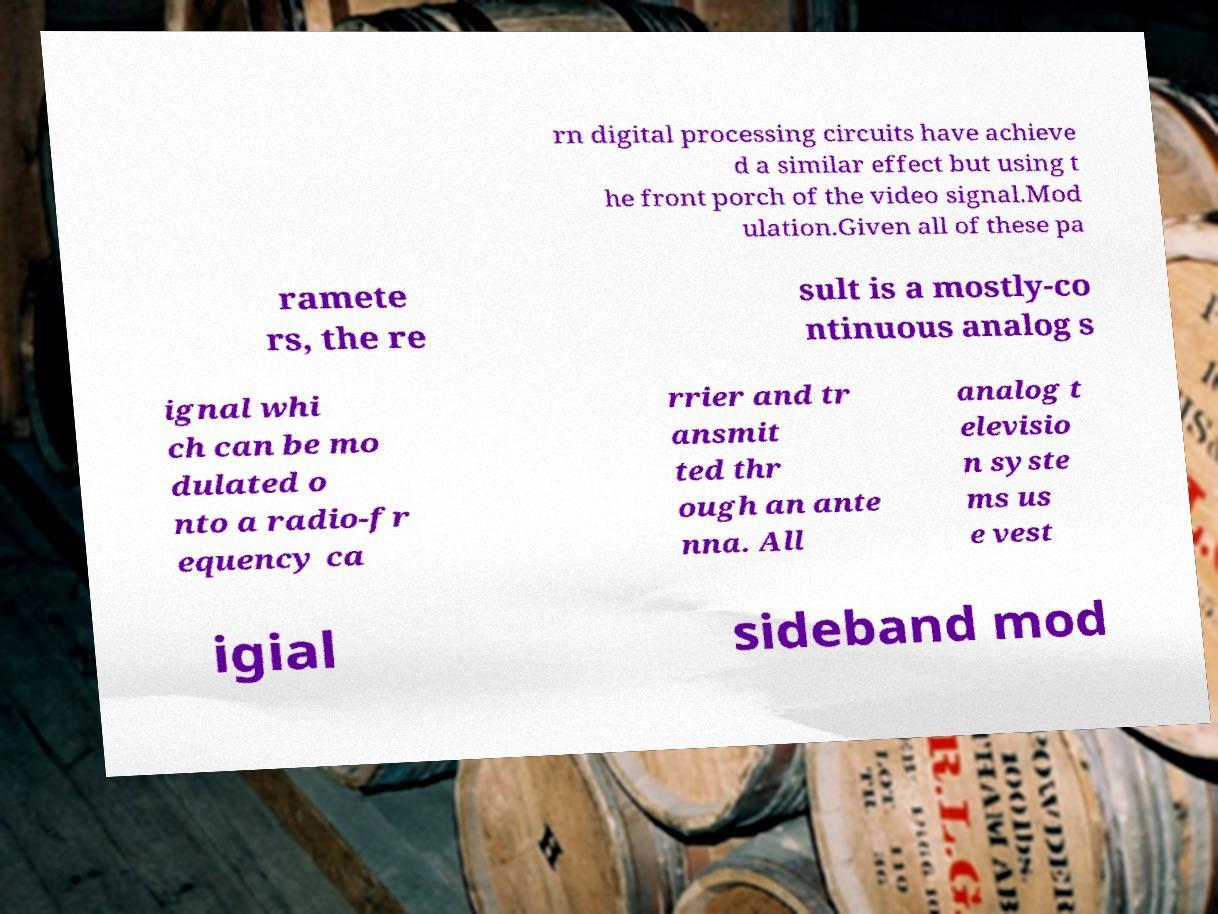What messages or text are displayed in this image? I need them in a readable, typed format. rn digital processing circuits have achieve d a similar effect but using t he front porch of the video signal.Mod ulation.Given all of these pa ramete rs, the re sult is a mostly-co ntinuous analog s ignal whi ch can be mo dulated o nto a radio-fr equency ca rrier and tr ansmit ted thr ough an ante nna. All analog t elevisio n syste ms us e vest igial sideband mod 